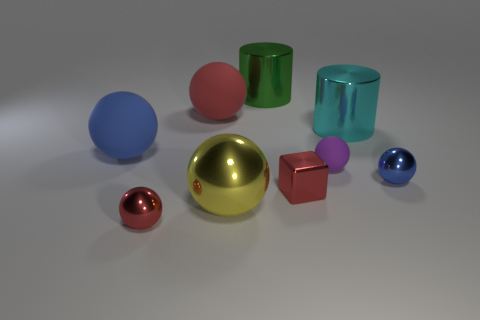Subtract all red balls. How many balls are left? 4 Subtract all blue cylinders. How many blue balls are left? 2 Subtract all purple spheres. How many spheres are left? 5 Subtract all balls. How many objects are left? 3 Subtract 2 balls. How many balls are left? 4 Subtract all green cubes. Subtract all cyan spheres. How many cubes are left? 1 Subtract all big cyan things. Subtract all green matte spheres. How many objects are left? 8 Add 1 large red matte balls. How many large red matte balls are left? 2 Add 3 big cylinders. How many big cylinders exist? 5 Subtract 0 yellow cylinders. How many objects are left? 9 